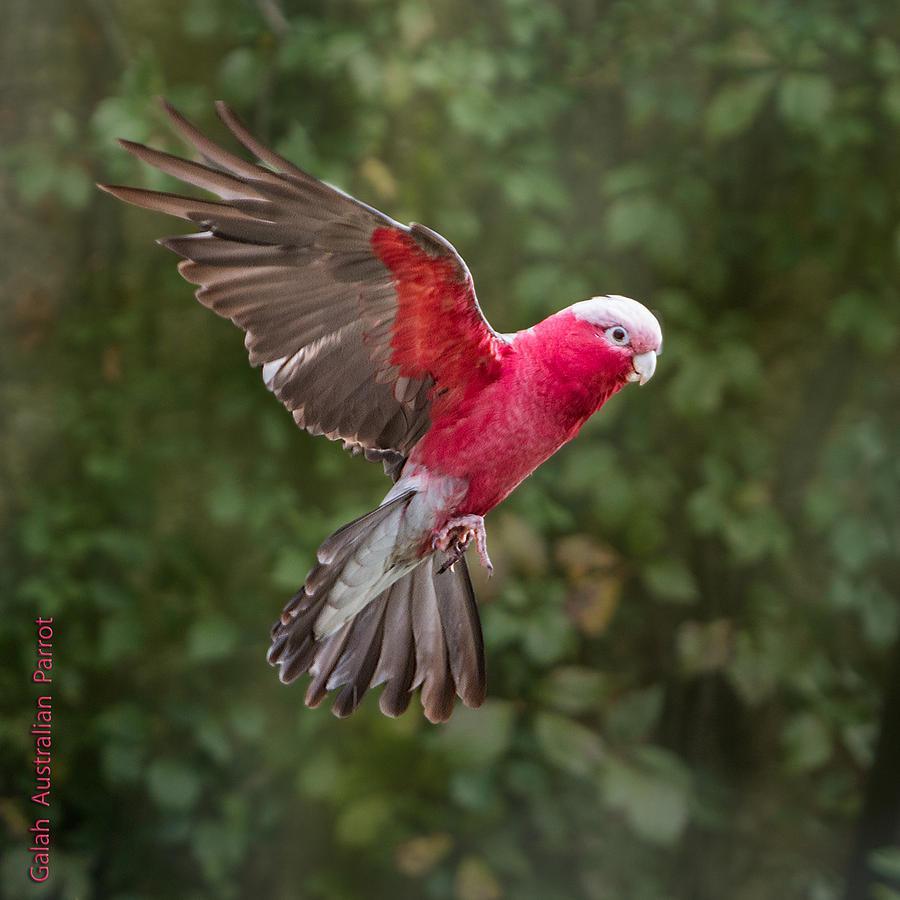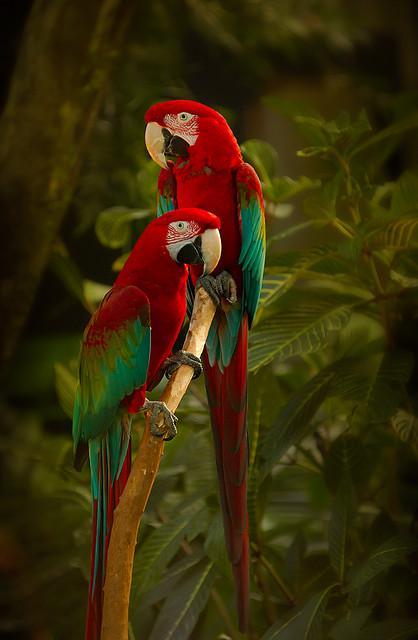The first image is the image on the left, the second image is the image on the right. For the images shown, is this caption "At least one of the images has two birds standing on the same branch." true? Answer yes or no. Yes. The first image is the image on the left, the second image is the image on the right. For the images shown, is this caption "In the paired images, only parrots with spread wings are shown." true? Answer yes or no. No. The first image is the image on the left, the second image is the image on the right. Examine the images to the left and right. Is the description "The parrot in the right image is flying." accurate? Answer yes or no. No. 